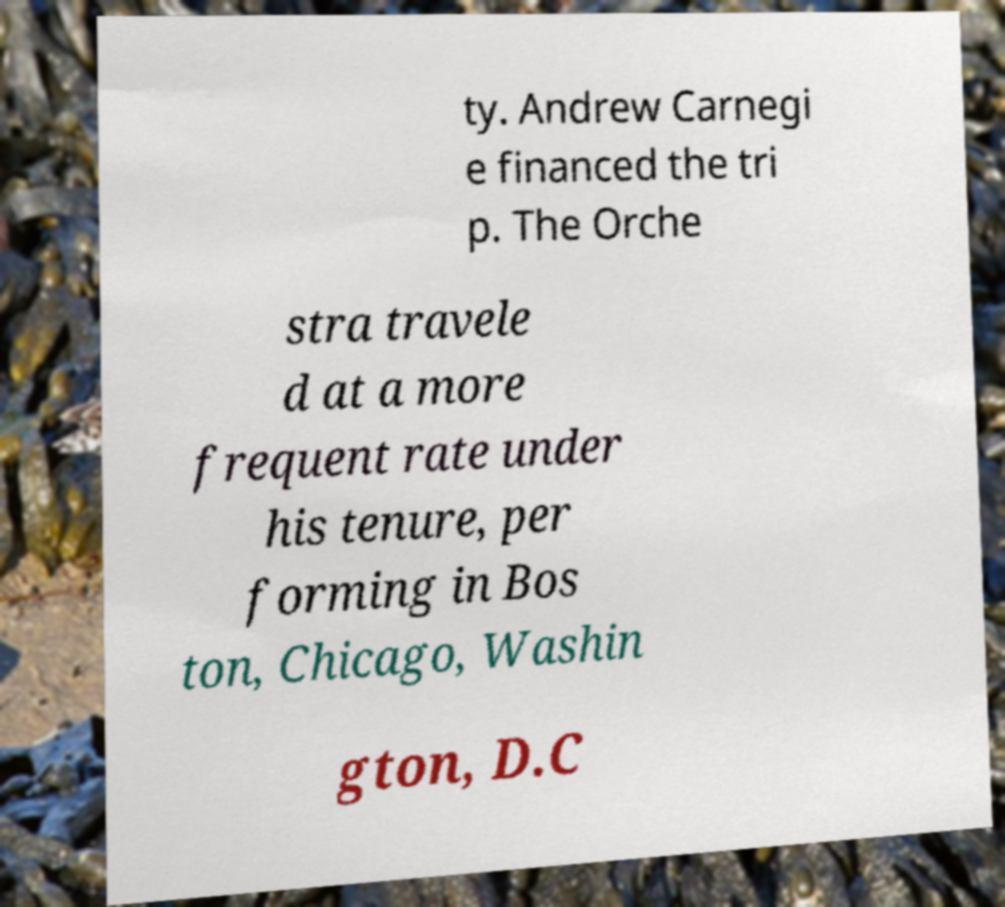Can you accurately transcribe the text from the provided image for me? ty. Andrew Carnegi e financed the tri p. The Orche stra travele d at a more frequent rate under his tenure, per forming in Bos ton, Chicago, Washin gton, D.C 